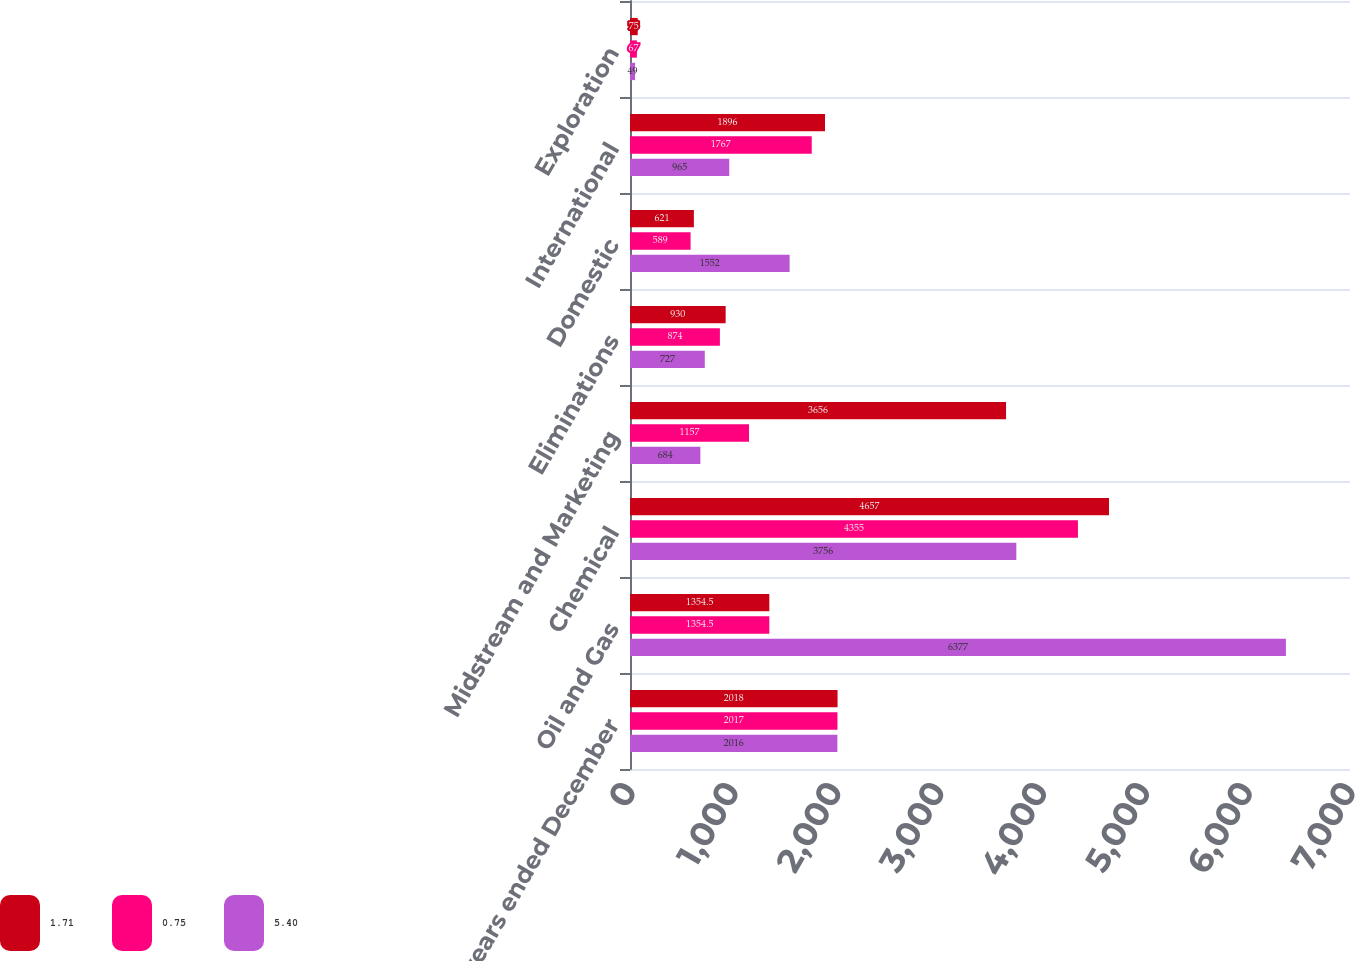Convert chart to OTSL. <chart><loc_0><loc_0><loc_500><loc_500><stacked_bar_chart><ecel><fcel>For the years ended December<fcel>Oil and Gas<fcel>Chemical<fcel>Midstream and Marketing<fcel>Eliminations<fcel>Domestic<fcel>International<fcel>Exploration<nl><fcel>1.71<fcel>2018<fcel>1354.5<fcel>4657<fcel>3656<fcel>930<fcel>621<fcel>1896<fcel>75<nl><fcel>0.75<fcel>2017<fcel>1354.5<fcel>4355<fcel>1157<fcel>874<fcel>589<fcel>1767<fcel>67<nl><fcel>5.4<fcel>2016<fcel>6377<fcel>3756<fcel>684<fcel>727<fcel>1552<fcel>965<fcel>49<nl></chart> 